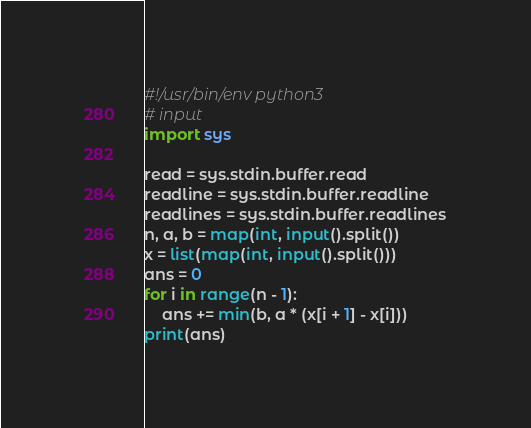Convert code to text. <code><loc_0><loc_0><loc_500><loc_500><_Python_>#!/usr/bin/env python3
# input
import sys

read = sys.stdin.buffer.read
readline = sys.stdin.buffer.readline
readlines = sys.stdin.buffer.readlines
n, a, b = map(int, input().split())
x = list(map(int, input().split()))
ans = 0
for i in range(n - 1):
    ans += min(b, a * (x[i + 1] - x[i]))
print(ans)
</code> 